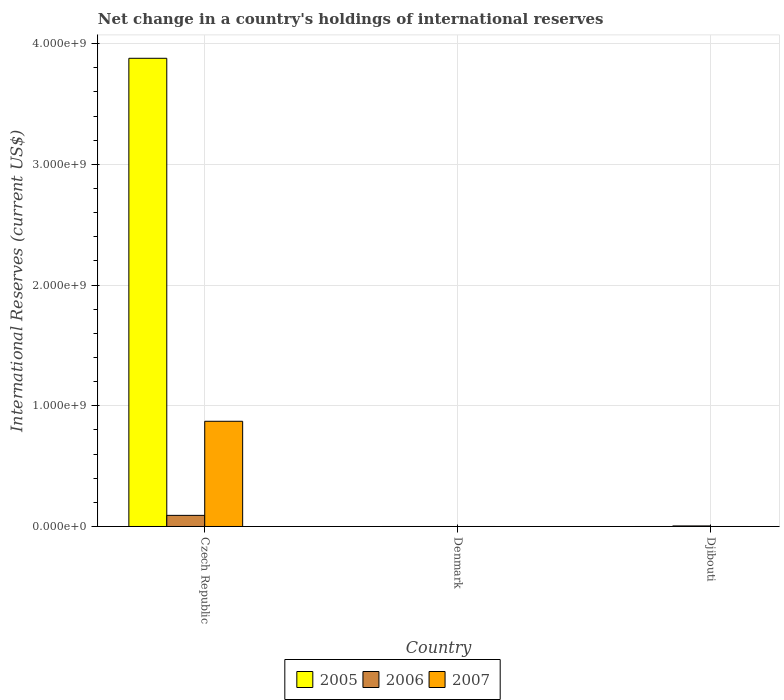Are the number of bars per tick equal to the number of legend labels?
Make the answer very short. No. In how many cases, is the number of bars for a given country not equal to the number of legend labels?
Make the answer very short. 2. Across all countries, what is the maximum international reserves in 2005?
Offer a very short reply. 3.88e+09. Across all countries, what is the minimum international reserves in 2007?
Give a very brief answer. 0. In which country was the international reserves in 2007 maximum?
Offer a very short reply. Czech Republic. What is the total international reserves in 2007 in the graph?
Your answer should be compact. 8.72e+08. What is the difference between the international reserves in 2006 in Czech Republic and that in Djibouti?
Your response must be concise. 8.74e+07. What is the difference between the international reserves in 2007 in Czech Republic and the international reserves in 2005 in Denmark?
Keep it short and to the point. 8.72e+08. What is the average international reserves in 2006 per country?
Keep it short and to the point. 3.22e+07. What is the difference between the international reserves of/in 2007 and international reserves of/in 2006 in Czech Republic?
Offer a very short reply. 7.80e+08. What is the ratio of the international reserves in 2006 in Czech Republic to that in Djibouti?
Offer a terse response. 19.8. What is the difference between the highest and the lowest international reserves in 2006?
Offer a very short reply. 9.21e+07. Is the sum of the international reserves in 2006 in Czech Republic and Djibouti greater than the maximum international reserves in 2005 across all countries?
Offer a very short reply. No. How many bars are there?
Your answer should be very brief. 4. Are all the bars in the graph horizontal?
Give a very brief answer. No. How many countries are there in the graph?
Your answer should be very brief. 3. Are the values on the major ticks of Y-axis written in scientific E-notation?
Keep it short and to the point. Yes. Does the graph contain grids?
Your response must be concise. Yes. Where does the legend appear in the graph?
Offer a terse response. Bottom center. How many legend labels are there?
Make the answer very short. 3. How are the legend labels stacked?
Your response must be concise. Horizontal. What is the title of the graph?
Provide a succinct answer. Net change in a country's holdings of international reserves. Does "1962" appear as one of the legend labels in the graph?
Your answer should be very brief. No. What is the label or title of the Y-axis?
Offer a terse response. International Reserves (current US$). What is the International Reserves (current US$) in 2005 in Czech Republic?
Offer a terse response. 3.88e+09. What is the International Reserves (current US$) in 2006 in Czech Republic?
Give a very brief answer. 9.21e+07. What is the International Reserves (current US$) of 2007 in Czech Republic?
Give a very brief answer. 8.72e+08. What is the International Reserves (current US$) in 2006 in Denmark?
Your response must be concise. 0. What is the International Reserves (current US$) in 2007 in Denmark?
Your answer should be compact. 0. What is the International Reserves (current US$) of 2005 in Djibouti?
Make the answer very short. 0. What is the International Reserves (current US$) of 2006 in Djibouti?
Offer a very short reply. 4.65e+06. Across all countries, what is the maximum International Reserves (current US$) in 2005?
Offer a terse response. 3.88e+09. Across all countries, what is the maximum International Reserves (current US$) of 2006?
Give a very brief answer. 9.21e+07. Across all countries, what is the maximum International Reserves (current US$) of 2007?
Keep it short and to the point. 8.72e+08. Across all countries, what is the minimum International Reserves (current US$) of 2005?
Offer a very short reply. 0. Across all countries, what is the minimum International Reserves (current US$) in 2006?
Give a very brief answer. 0. What is the total International Reserves (current US$) of 2005 in the graph?
Your answer should be compact. 3.88e+09. What is the total International Reserves (current US$) in 2006 in the graph?
Your response must be concise. 9.67e+07. What is the total International Reserves (current US$) of 2007 in the graph?
Ensure brevity in your answer.  8.72e+08. What is the difference between the International Reserves (current US$) of 2006 in Czech Republic and that in Djibouti?
Provide a short and direct response. 8.74e+07. What is the difference between the International Reserves (current US$) of 2005 in Czech Republic and the International Reserves (current US$) of 2006 in Djibouti?
Make the answer very short. 3.87e+09. What is the average International Reserves (current US$) in 2005 per country?
Provide a short and direct response. 1.29e+09. What is the average International Reserves (current US$) in 2006 per country?
Give a very brief answer. 3.22e+07. What is the average International Reserves (current US$) in 2007 per country?
Your answer should be very brief. 2.91e+08. What is the difference between the International Reserves (current US$) in 2005 and International Reserves (current US$) in 2006 in Czech Republic?
Your response must be concise. 3.79e+09. What is the difference between the International Reserves (current US$) in 2005 and International Reserves (current US$) in 2007 in Czech Republic?
Your answer should be very brief. 3.01e+09. What is the difference between the International Reserves (current US$) in 2006 and International Reserves (current US$) in 2007 in Czech Republic?
Offer a terse response. -7.80e+08. What is the ratio of the International Reserves (current US$) of 2006 in Czech Republic to that in Djibouti?
Your answer should be compact. 19.8. What is the difference between the highest and the lowest International Reserves (current US$) of 2005?
Make the answer very short. 3.88e+09. What is the difference between the highest and the lowest International Reserves (current US$) of 2006?
Your answer should be very brief. 9.21e+07. What is the difference between the highest and the lowest International Reserves (current US$) in 2007?
Provide a short and direct response. 8.72e+08. 